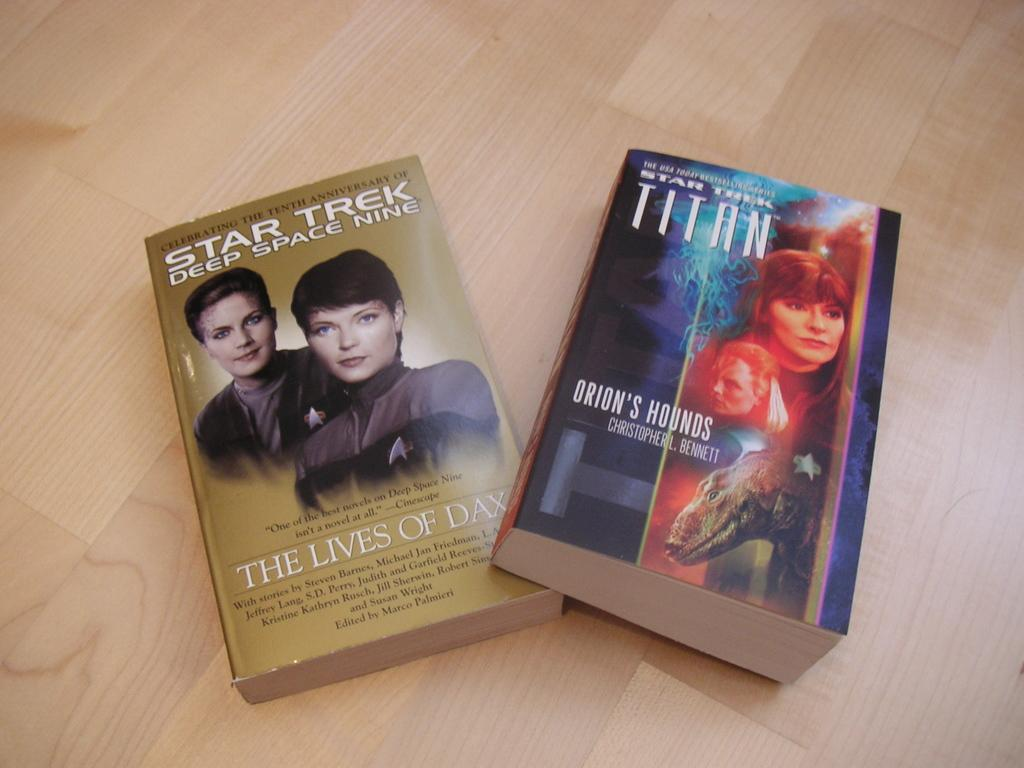What objects are located in the center of the image? There are two books in the center of the image. What can be seen at the bottom of the image? There is a floor visible at the bottom of the image. What is written on the books? There is text on the books. What is depicted on the books? There are persons on the books. What type of cloth is being used to mark the person's spot on the book? There is no cloth present in the image, nor is there any indication of someone marking their spot on the book. 